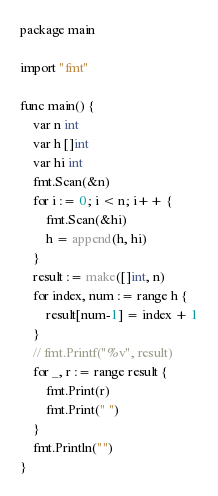<code> <loc_0><loc_0><loc_500><loc_500><_Go_>package main

import "fmt"

func main() {
	var n int
	var h []int
	var hi int
	fmt.Scan(&n)
	for i := 0; i < n; i++ {
		fmt.Scan(&hi)
		h = append(h, hi)
	}
	result := make([]int, n)
	for index, num := range h {
		result[num-1] = index + 1
	}
	// fmt.Printf("%v", result)
	for _, r := range result {
		fmt.Print(r)
		fmt.Print(" ")
	}
	fmt.Println("")
}
</code> 